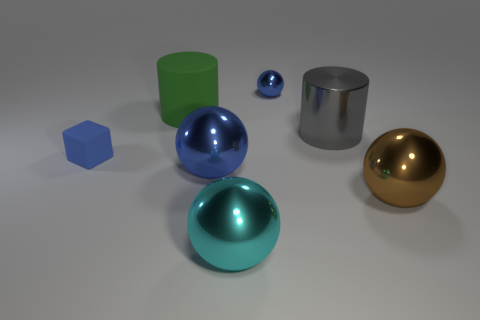Subtract all large metal balls. How many balls are left? 1 Add 1 big matte things. How many objects exist? 8 Subtract 2 spheres. How many spheres are left? 2 Add 6 small metallic things. How many small metallic things exist? 7 Subtract all brown spheres. How many spheres are left? 3 Subtract 0 purple balls. How many objects are left? 7 Subtract all balls. How many objects are left? 3 Subtract all cyan cylinders. Subtract all green blocks. How many cylinders are left? 2 Subtract all blue spheres. How many cyan cubes are left? 0 Subtract all brown metal objects. Subtract all blue rubber cubes. How many objects are left? 5 